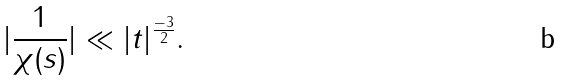<formula> <loc_0><loc_0><loc_500><loc_500>| \frac { 1 } { \chi ( s ) } | \ll | t | ^ { \frac { - 3 } { 2 } } .</formula> 